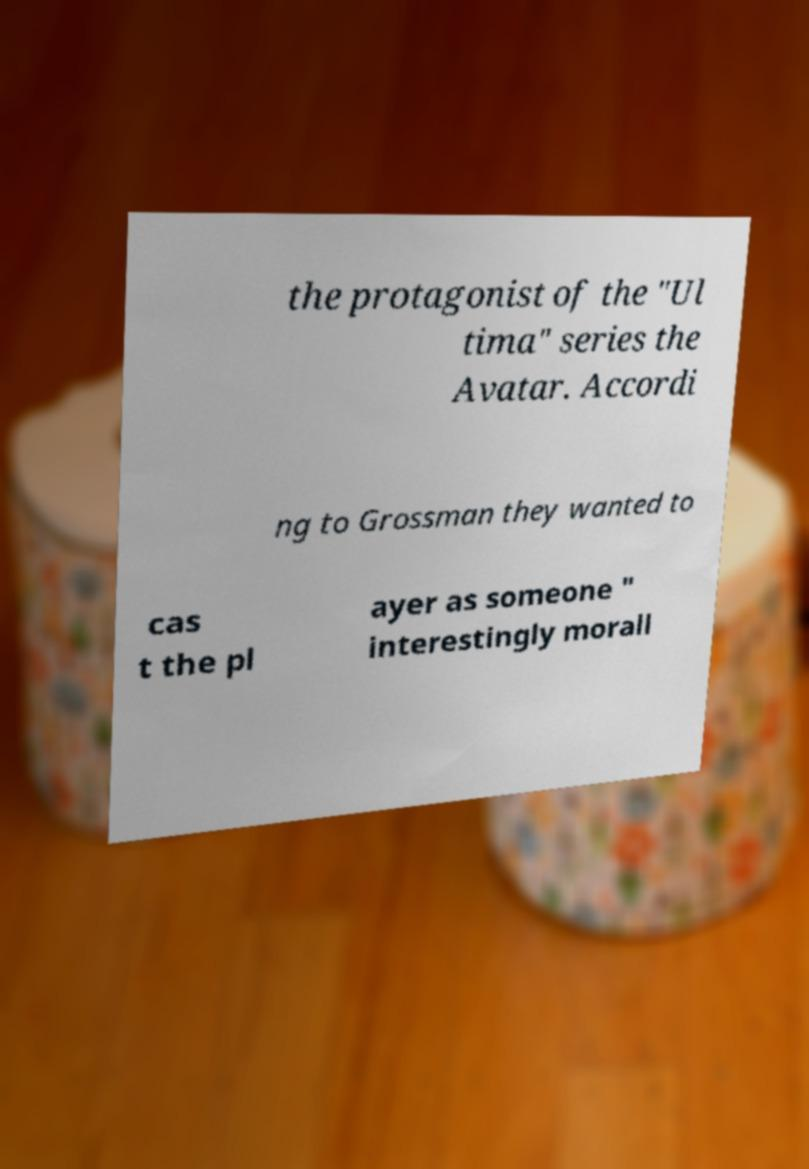Could you assist in decoding the text presented in this image and type it out clearly? the protagonist of the "Ul tima" series the Avatar. Accordi ng to Grossman they wanted to cas t the pl ayer as someone " interestingly morall 